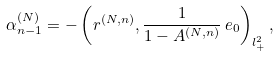Convert formula to latex. <formula><loc_0><loc_0><loc_500><loc_500>\alpha _ { n - 1 } ^ { ( N ) } = - \left ( r ^ { ( N , n ) } , \frac { 1 } { 1 - A ^ { ( N , n ) } } \, e _ { 0 } \right ) _ { l ^ { 2 } _ { + } } ,</formula> 